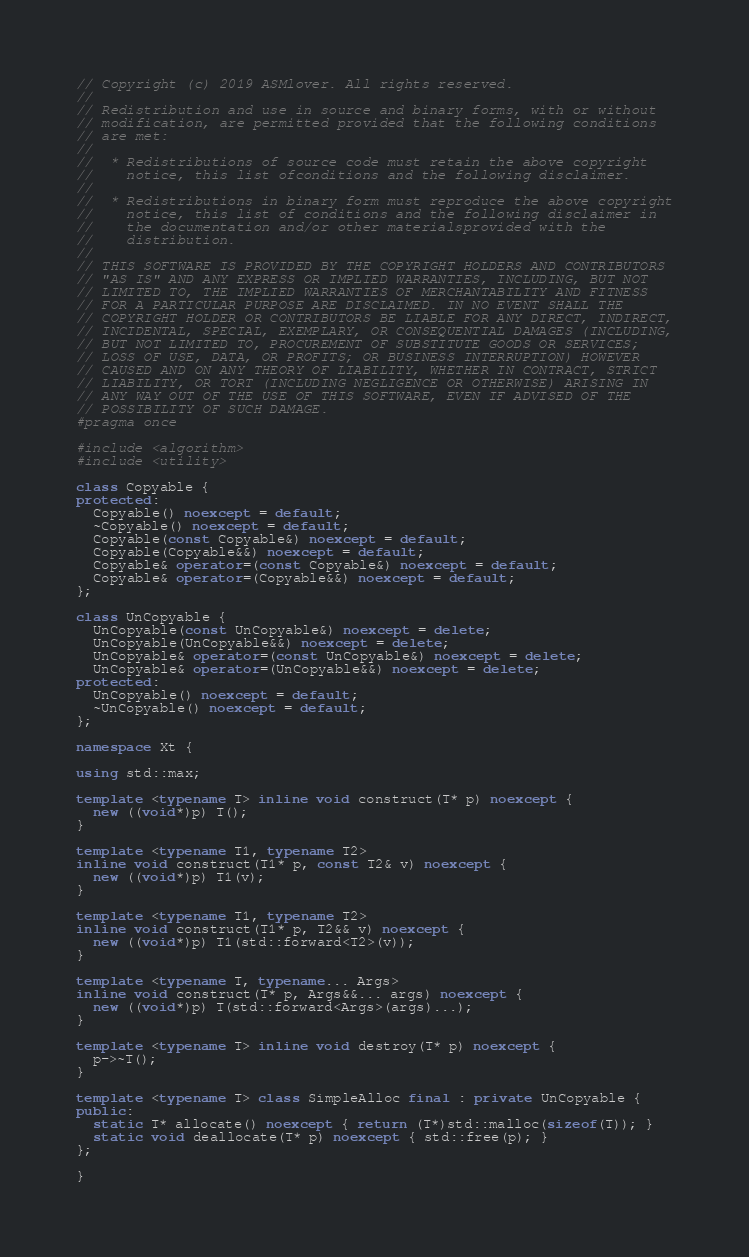<code> <loc_0><loc_0><loc_500><loc_500><_C++_>// Copyright (c) 2019 ASMlover. All rights reserved.
//
// Redistribution and use in source and binary forms, with or without
// modification, are permitted provided that the following conditions
// are met:
//
//  * Redistributions of source code must retain the above copyright
//    notice, this list ofconditions and the following disclaimer.
//
//  * Redistributions in binary form must reproduce the above copyright
//    notice, this list of conditions and the following disclaimer in
//    the documentation and/or other materialsprovided with the
//    distribution.
//
// THIS SOFTWARE IS PROVIDED BY THE COPYRIGHT HOLDERS AND CONTRIBUTORS
// "AS IS" AND ANY EXPRESS OR IMPLIED WARRANTIES, INCLUDING, BUT NOT
// LIMITED TO, THE IMPLIED WARRANTIES OF MERCHANTABILITY AND FITNESS
// FOR A PARTICULAR PURPOSE ARE DISCLAIMED. IN NO EVENT SHALL THE
// COPYRIGHT HOLDER OR CONTRIBUTORS BE LIABLE FOR ANY DIRECT, INDIRECT,
// INCIDENTAL, SPECIAL, EXEMPLARY, OR CONSEQUENTIAL DAMAGES (INCLUDING,
// BUT NOT LIMITED TO, PROCUREMENT OF SUBSTITUTE GOODS OR SERVICES;
// LOSS OF USE, DATA, OR PROFITS; OR BUSINESS INTERRUPTION) HOWEVER
// CAUSED AND ON ANY THEORY OF LIABILITY, WHETHER IN CONTRACT, STRICT
// LIABILITY, OR TORT (INCLUDING NEGLIGENCE OR OTHERWISE) ARISING IN
// ANY WAY OUT OF THE USE OF THIS SOFTWARE, EVEN IF ADVISED OF THE
// POSSIBILITY OF SUCH DAMAGE.
#pragma once

#include <algorithm>
#include <utility>

class Copyable {
protected:
  Copyable() noexcept = default;
  ~Copyable() noexcept = default;
  Copyable(const Copyable&) noexcept = default;
  Copyable(Copyable&&) noexcept = default;
  Copyable& operator=(const Copyable&) noexcept = default;
  Copyable& operator=(Copyable&&) noexcept = default;
};

class UnCopyable {
  UnCopyable(const UnCopyable&) noexcept = delete;
  UnCopyable(UnCopyable&&) noexcept = delete;
  UnCopyable& operator=(const UnCopyable&) noexcept = delete;
  UnCopyable& operator=(UnCopyable&&) noexcept = delete;
protected:
  UnCopyable() noexcept = default;
  ~UnCopyable() noexcept = default;
};

namespace Xt {

using std::max;

template <typename T> inline void construct(T* p) noexcept {
  new ((void*)p) T();
}

template <typename T1, typename T2>
inline void construct(T1* p, const T2& v) noexcept {
  new ((void*)p) T1(v);
}

template <typename T1, typename T2>
inline void construct(T1* p, T2&& v) noexcept {
  new ((void*)p) T1(std::forward<T2>(v));
}

template <typename T, typename... Args>
inline void construct(T* p, Args&&... args) noexcept {
  new ((void*)p) T(std::forward<Args>(args)...);
}

template <typename T> inline void destroy(T* p) noexcept {
  p->~T();
}

template <typename T> class SimpleAlloc final : private UnCopyable {
public:
  static T* allocate() noexcept { return (T*)std::malloc(sizeof(T)); }
  static void deallocate(T* p) noexcept { std::free(p); }
};

}
</code> 